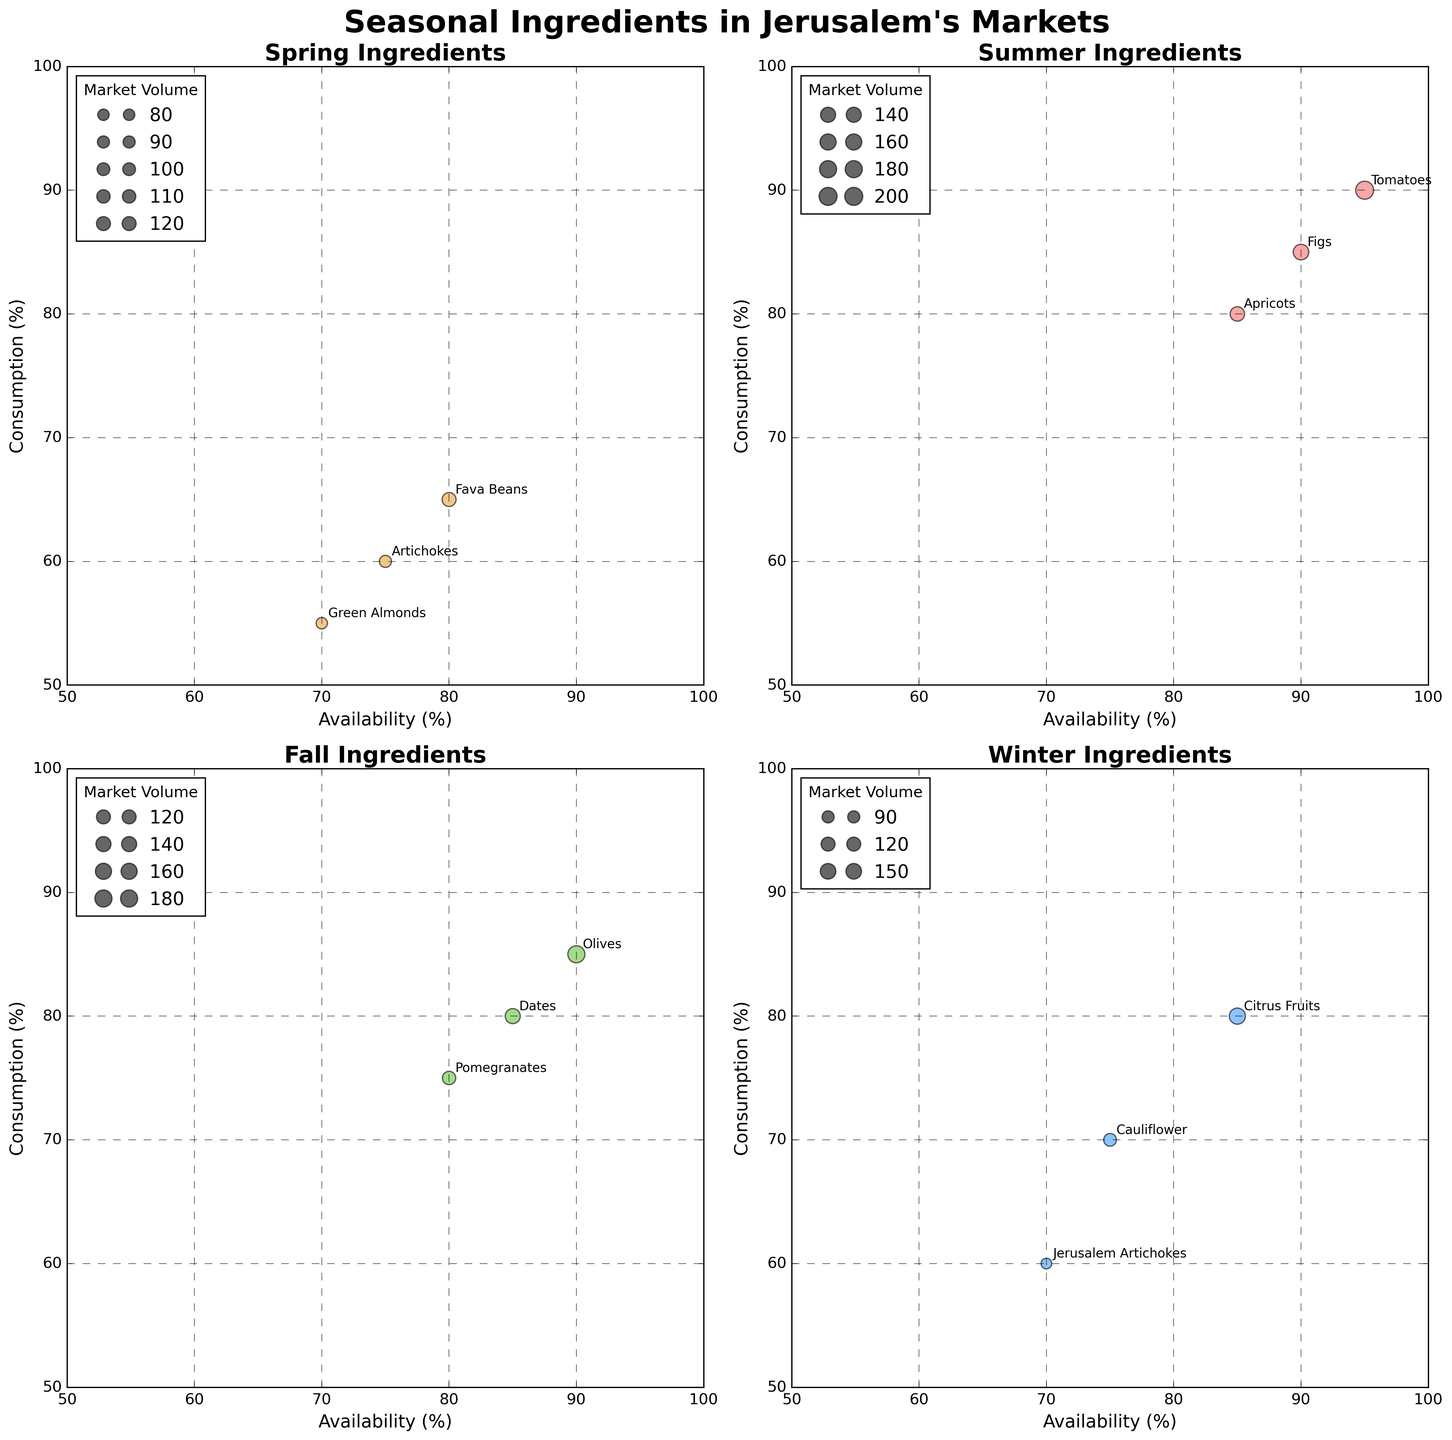What is the title of the figure? The title of the figure is located at the top and is usually in a larger, bold font. This title gives an overview of what the figure is about.
Answer: Seasonal Ingredients in Jerusalem's Markets How many seasonal subplots are there in the figure? The figure's layout is divided into multiple sections, each representing a different season. Each section or subplot focuses on one season.
Answer: 4 Which ingredient has the highest consumption in summer? To determine this, locate the summer subplot and find the data point with the highest value on the y-axis, which represents consumption.
Answer: Tomatoes What are the x and y-axis labels for each subplot? The x-axis and y-axis labels are consistent across all subplots and indicate what each axis measures. These labels help interpret the data points.
Answer: Availability (%), Consumption (%) Which seasons have ingredients with market volumes over 1500? Look for the size of the bubbles in each subplot. Larger bubbles indicate higher market volumes. Identify the seasons where these large bubbles are present.
Answer: Summer, Winter How does the consumption of Green Almonds in Spring compare to Figs in Summer? Locate the data points for Green Almonds in the Spring subplot and Figs in the Summer subplot, then compare their y-axis values.
Answer: Figs in Summer have higher consumption Which season has the ingredient with the lowest availability? Identify the data point with the lowest x-axis value from each subplot and compare these values across the four seasons.
Answer: Winter (Jerusalem Artichokes) What is the average market volume of ingredients in Fall? Sum the market volumes of all ingredients in Fall and then divide by the number of ingredients to get the average.
Answer: (1100 + 1400 + 1800) / 3 = 1433.33 Which ingredient has the highest difference between availability and consumption in any season? For each ingredient, subtract the consumption percentage from the availability percentage. Identify the ingredient with the largest result.
Answer: Fava Beans (Spring) Are there any ingredients with equal availability and consumption in any season? Check if any data points in any subplot have the same values on the x-axis and y-axis, indicating equal availability and consumption percentages.
Answer: No 